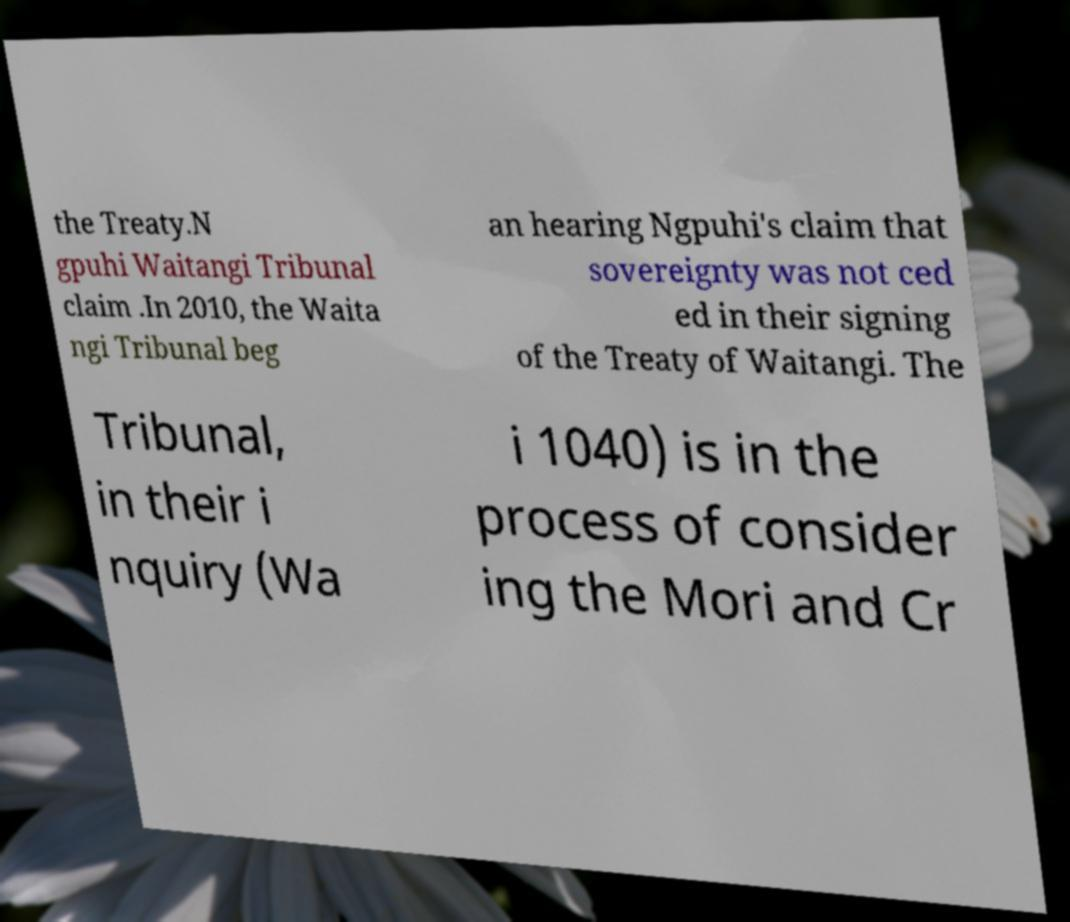Can you read and provide the text displayed in the image?This photo seems to have some interesting text. Can you extract and type it out for me? the Treaty.N gpuhi Waitangi Tribunal claim .In 2010, the Waita ngi Tribunal beg an hearing Ngpuhi's claim that sovereignty was not ced ed in their signing of the Treaty of Waitangi. The Tribunal, in their i nquiry (Wa i 1040) is in the process of consider ing the Mori and Cr 